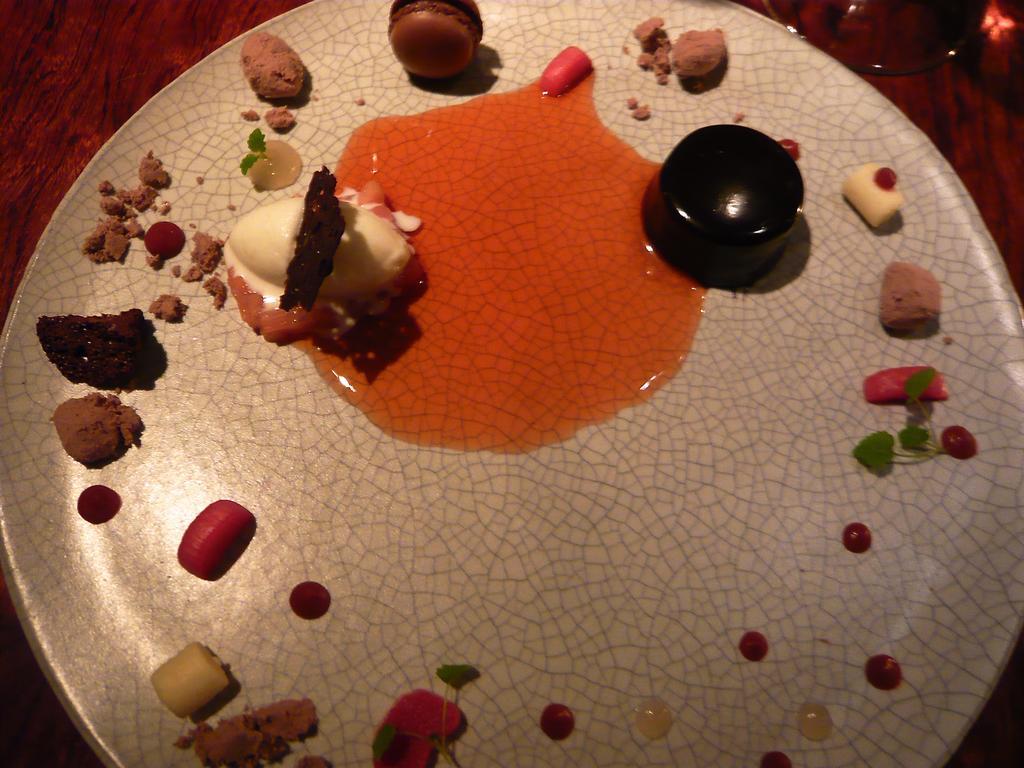Describe this image in one or two sentences. In this image there is a plate truncated, there are objects in the plate, there is a glass truncated towards the top of the image. 